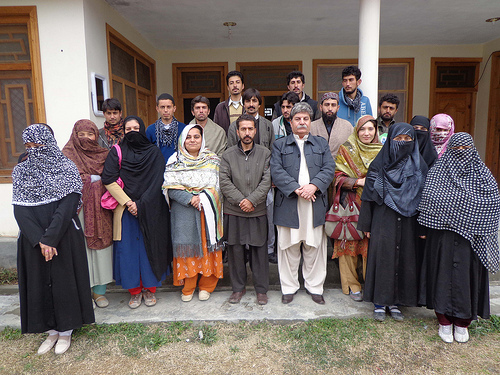<image>
Is the grass under the man? No. The grass is not positioned under the man. The vertical relationship between these objects is different. 